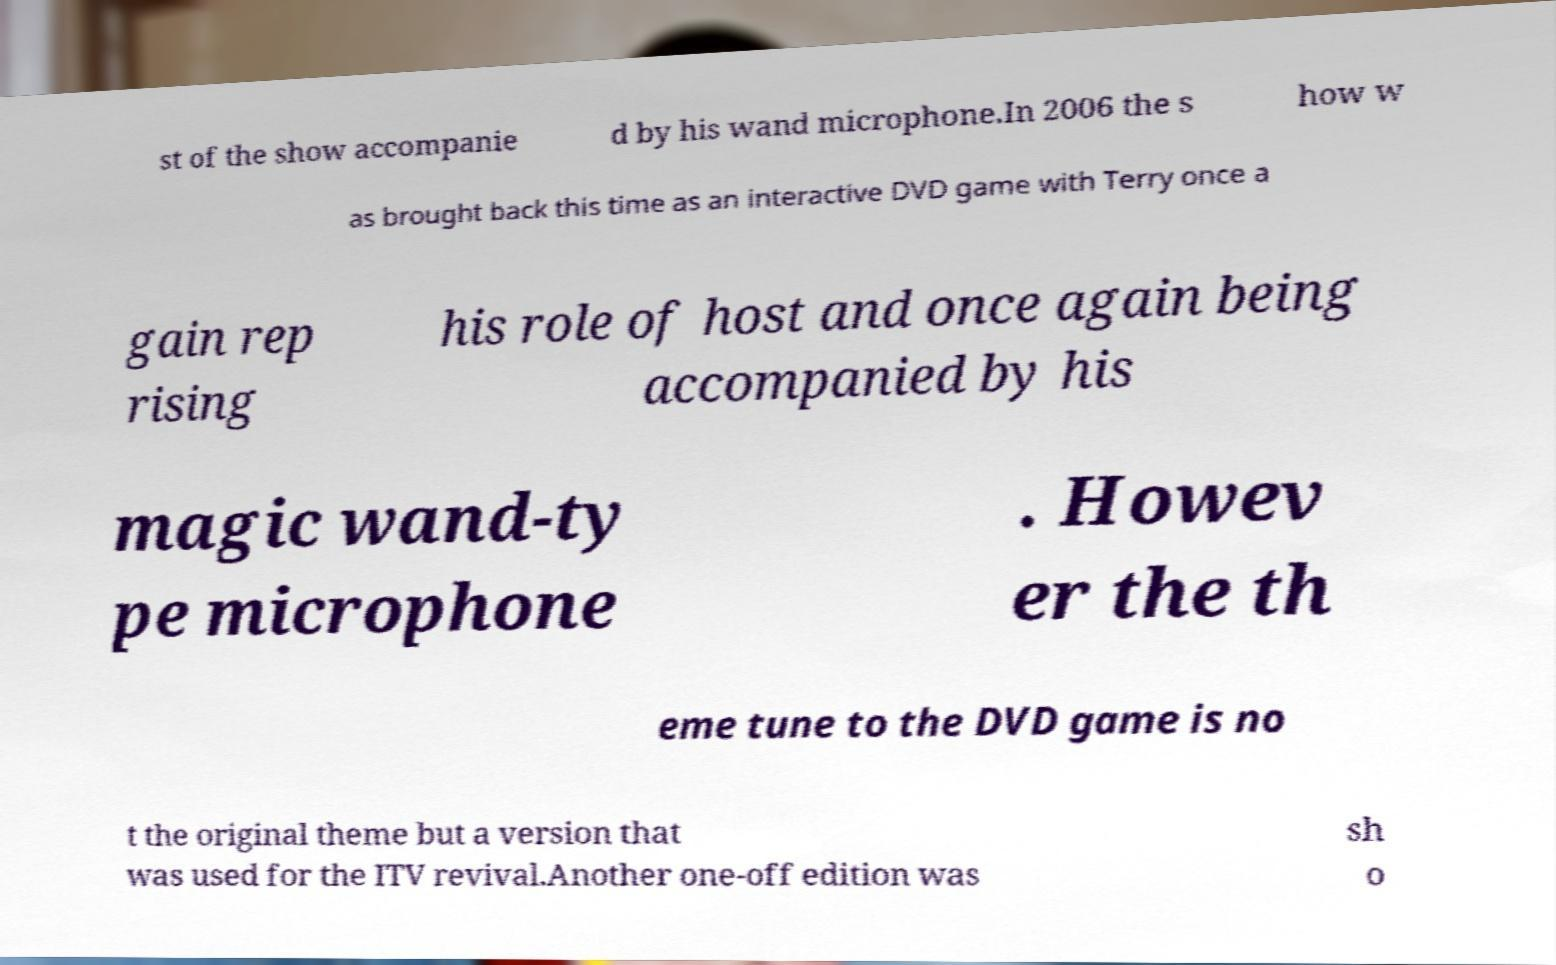There's text embedded in this image that I need extracted. Can you transcribe it verbatim? st of the show accompanie d by his wand microphone.In 2006 the s how w as brought back this time as an interactive DVD game with Terry once a gain rep rising his role of host and once again being accompanied by his magic wand-ty pe microphone . Howev er the th eme tune to the DVD game is no t the original theme but a version that was used for the ITV revival.Another one-off edition was sh o 